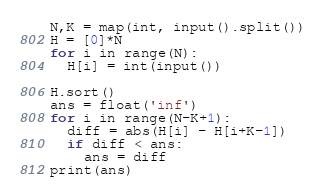<code> <loc_0><loc_0><loc_500><loc_500><_Python_>N,K = map(int, input().split())
H = [0]*N
for i in range(N):
  H[i] = int(input())

H.sort()
ans = float('inf')
for i in range(N-K+1):
  diff = abs(H[i] - H[i+K-1])
  if diff < ans:
    ans = diff
print(ans)</code> 